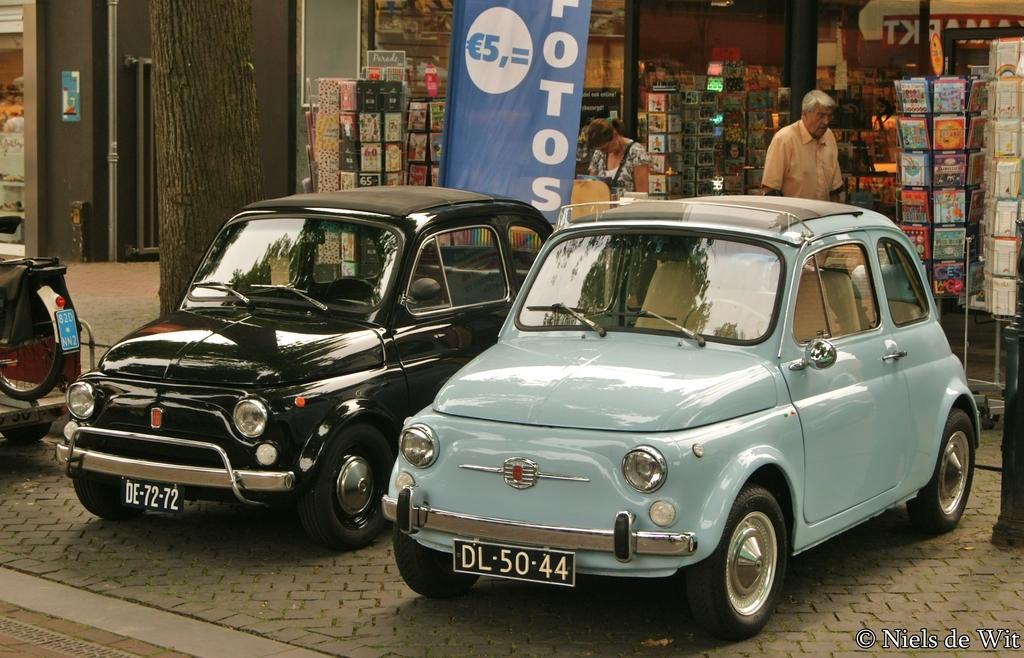Could you give a brief overview of what you see in this image? In this picture we can see two cars in the front, in the background there is a store, we can see two persons are standing in the middle, they are looking like books in the store, we can also see a hoarding in the middle, on the left side there is a tree and a pole, at the right bottom we can see some text. 